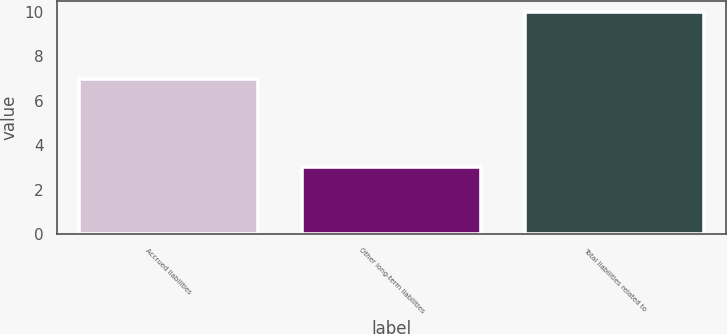Convert chart to OTSL. <chart><loc_0><loc_0><loc_500><loc_500><bar_chart><fcel>Accrued liabilities<fcel>Other long-term liabilities<fcel>Total liabilities related to<nl><fcel>7<fcel>3<fcel>10<nl></chart> 